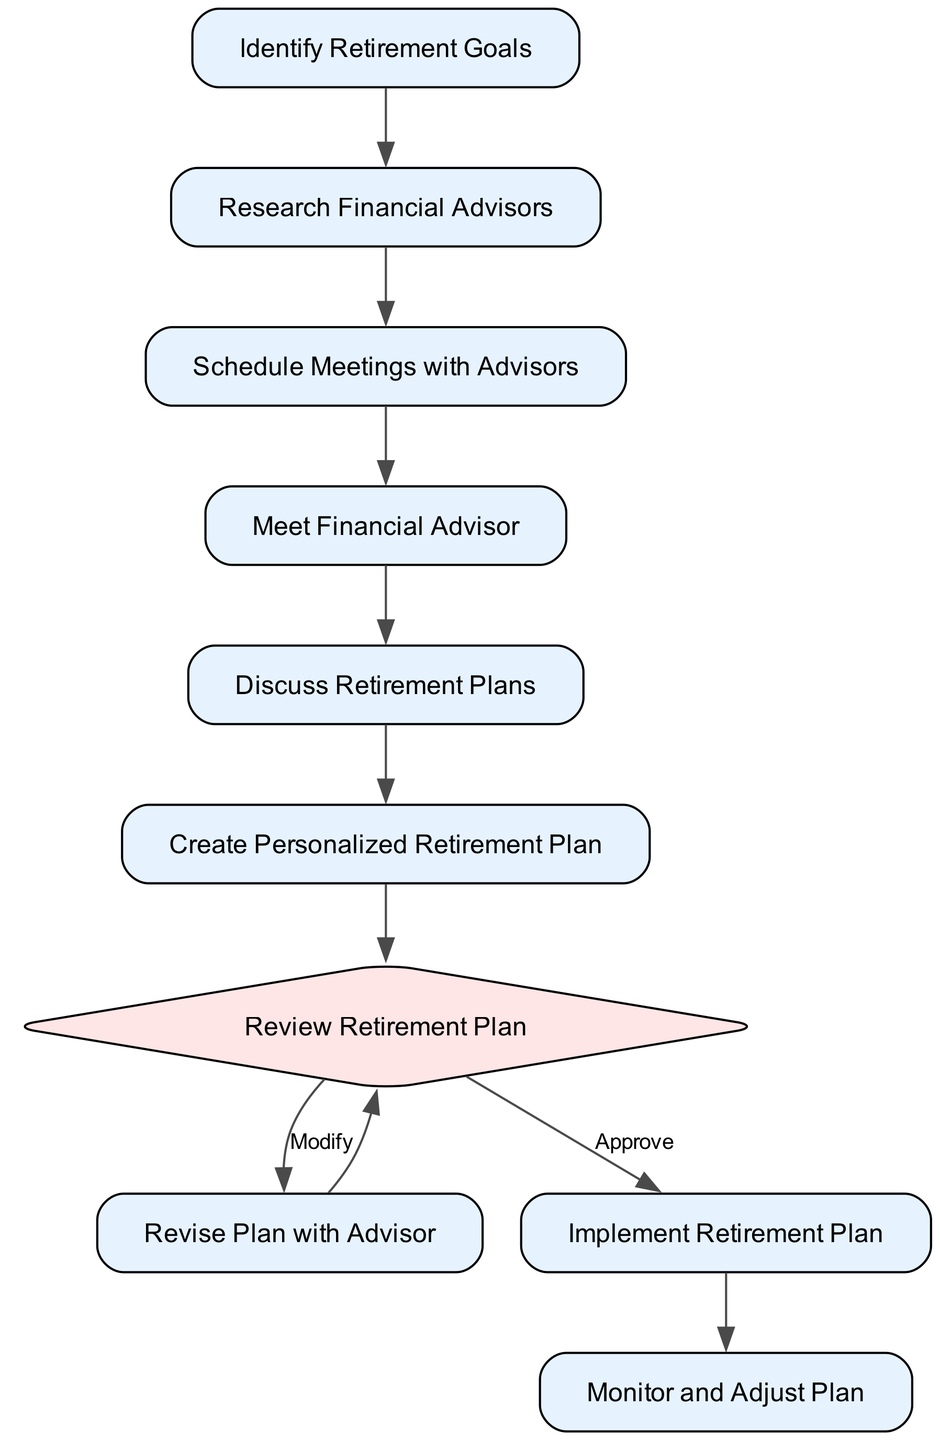What is the first action in the diagram? The first node in the activity diagram is "Identify Retirement Goals," which is connected to the next action.
Answer: Identify Retirement Goals How many total actions are there in the diagram? By counting the nodes labeled as actions, we find that there are six actions: "Identify Retirement Goals," "Research Financial Advisors," "Schedule Meetings with Advisors," "Meet Financial Advisor," "Discuss Retirement Plans," "Create Personalized Retirement Plan," "Revise Plan with Advisor," "Implement Retirement Plan," and "Monitor and Adjust Plan." Therefore, the total is six.
Answer: Six What comes after "Research Financial Advisors"? Following the diagram's connections, the node "Research Financial Advisors" points significantly to the next action, which is "Schedule Meetings with Advisors."
Answer: Schedule Meetings with Advisors What are the two choices after reviewing the retirement plan? After "Review Retirement Plan," there are two possible outcomes indicated: if approved, it moves to "Implement Retirement Plan," or if modified, it leads to "Revise Plan with Advisor." Thus, the choices are "Approve" and "Modify."
Answer: Approve and Modify If the plan is modified, what is the next activity? In the diagram, if the "Review Retirement Plan" decision results in "Modify," the next action is "Revise Plan with Advisor." This follows directly from the flow of activities outlined in the diagram.
Answer: Revise Plan with Advisor What type of node is "Review Retirement Plan"? "Review Retirement Plan" is a decision node because it has two branching choices associated with it: "Approve" and "Modify." This type of node is typically represented as a diamond shape in activity diagrams.
Answer: Decision What is the last action in the sequence? By looking at the flow of activities, the last action after implementing the retirement plan is "Monitor and Adjust Plan," which signifies continual oversight of the retirement strategy.
Answer: Monitor and Adjust Plan How many decision points are there in the diagram? The diagram has one decision point, found at the "Review Retirement Plan," where the choice affects future actions that follow this node.
Answer: One 